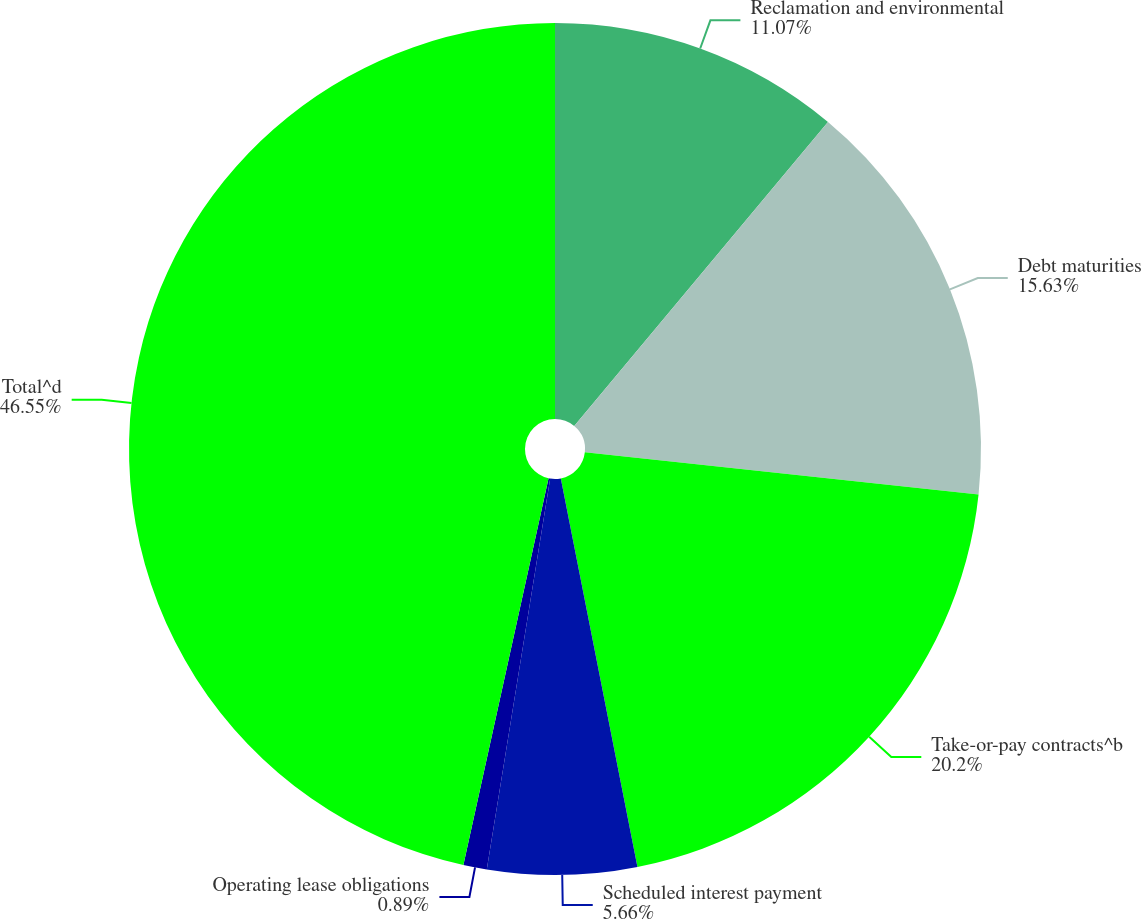Convert chart to OTSL. <chart><loc_0><loc_0><loc_500><loc_500><pie_chart><fcel>Reclamation and environmental<fcel>Debt maturities<fcel>Take-or-pay contracts^b<fcel>Scheduled interest payment<fcel>Operating lease obligations<fcel>Total^d<nl><fcel>11.07%<fcel>15.63%<fcel>20.2%<fcel>5.66%<fcel>0.89%<fcel>46.55%<nl></chart> 